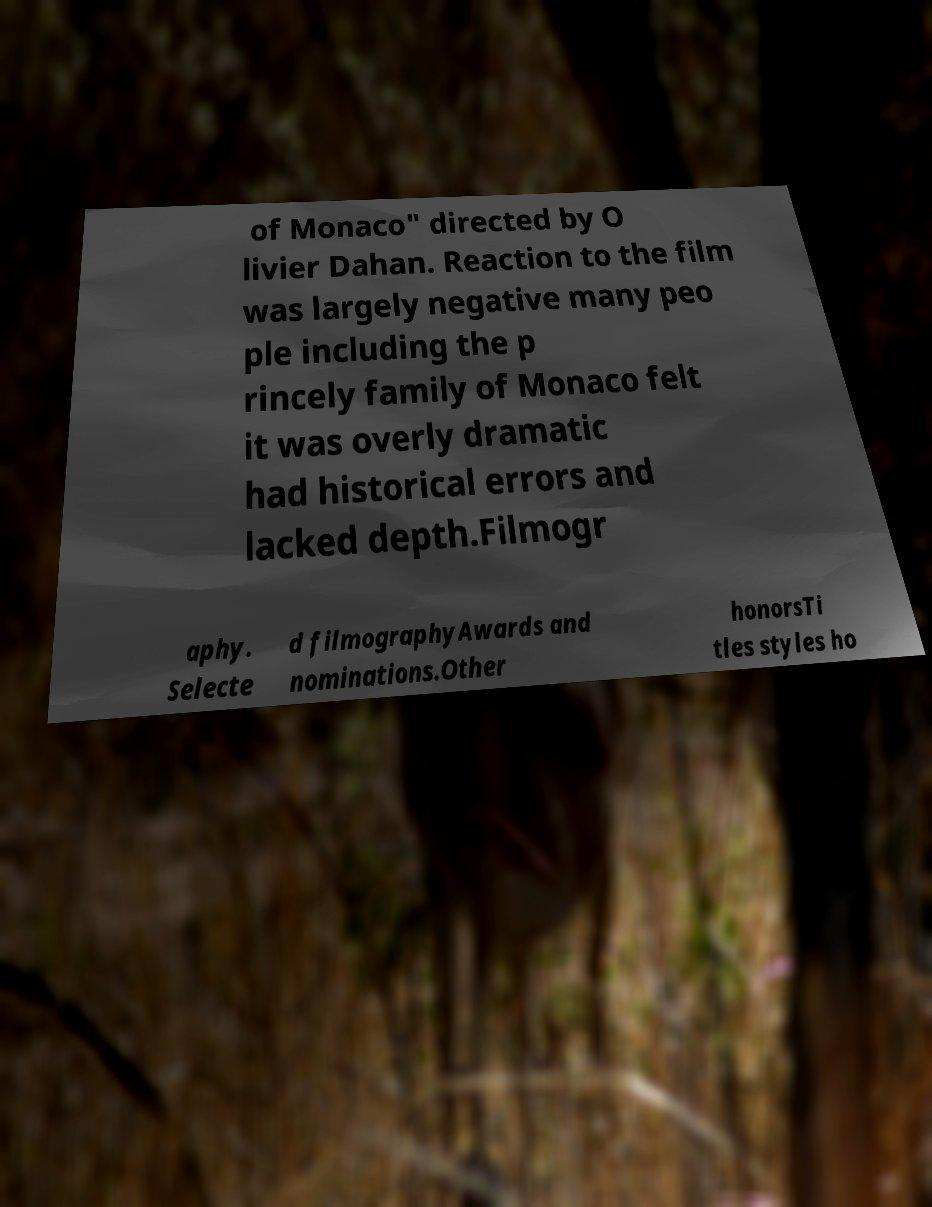Please identify and transcribe the text found in this image. of Monaco" directed by O livier Dahan. Reaction to the film was largely negative many peo ple including the p rincely family of Monaco felt it was overly dramatic had historical errors and lacked depth.Filmogr aphy. Selecte d filmographyAwards and nominations.Other honorsTi tles styles ho 